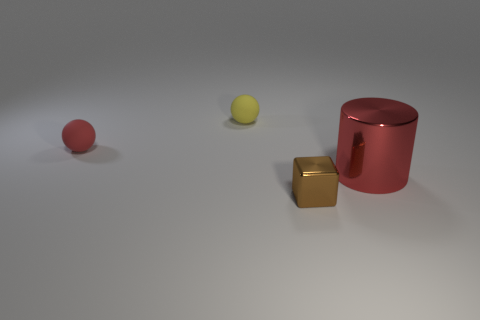There is a red thing that is on the left side of the small yellow rubber object; what number of spheres are to the right of it?
Ensure brevity in your answer.  1. There is a block that is the same size as the yellow ball; what is its material?
Your answer should be compact. Metal. Does the matte thing that is in front of the tiny yellow ball have the same shape as the tiny yellow thing?
Your answer should be very brief. Yes. Is the number of tiny brown cubes behind the tiny red sphere greater than the number of tiny brown shiny things behind the red metallic cylinder?
Provide a short and direct response. No. What number of brown objects are made of the same material as the small red object?
Your response must be concise. 0. Is the size of the block the same as the yellow matte sphere?
Your response must be concise. Yes. The block is what color?
Provide a succinct answer. Brown. What number of things are either purple balls or yellow matte spheres?
Give a very brief answer. 1. Is there a red object of the same shape as the small yellow thing?
Your response must be concise. Yes. Do the rubber sphere in front of the tiny yellow thing and the shiny cylinder have the same color?
Provide a succinct answer. Yes. 